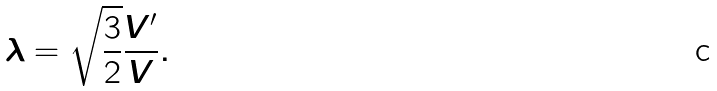Convert formula to latex. <formula><loc_0><loc_0><loc_500><loc_500>\lambda = \sqrt { \frac { 3 } { 2 } } \frac { V ^ { \prime } } { V } .</formula> 